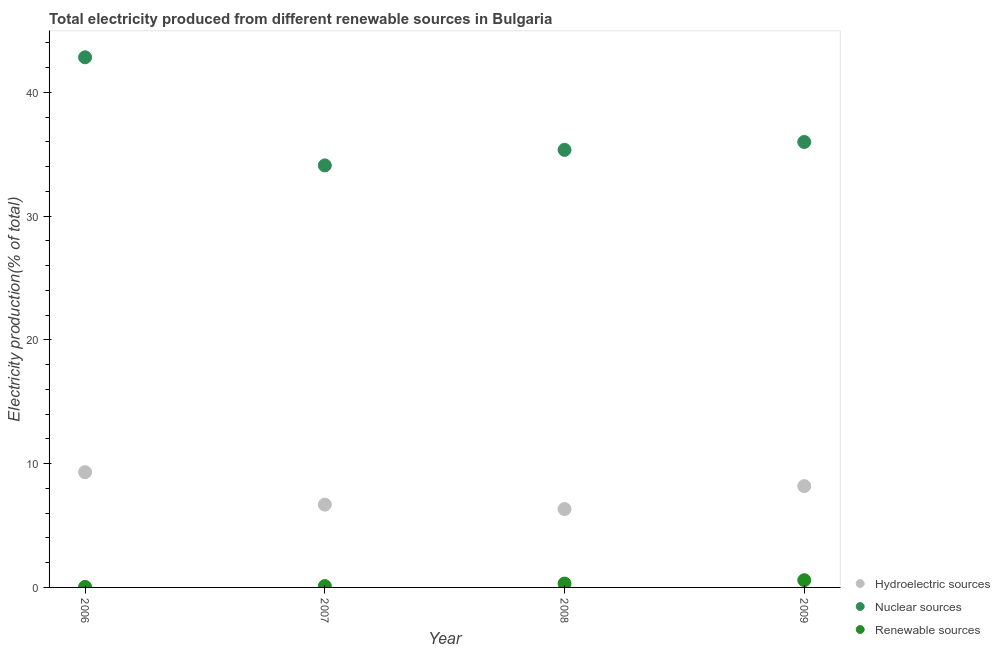How many different coloured dotlines are there?
Give a very brief answer. 3. Is the number of dotlines equal to the number of legend labels?
Keep it short and to the point. Yes. What is the percentage of electricity produced by renewable sources in 2008?
Your response must be concise. 0.31. Across all years, what is the maximum percentage of electricity produced by nuclear sources?
Give a very brief answer. 42.84. Across all years, what is the minimum percentage of electricity produced by renewable sources?
Your answer should be very brief. 0.04. What is the total percentage of electricity produced by renewable sources in the graph?
Provide a succinct answer. 1.05. What is the difference between the percentage of electricity produced by hydroelectric sources in 2008 and that in 2009?
Offer a very short reply. -1.85. What is the difference between the percentage of electricity produced by renewable sources in 2007 and the percentage of electricity produced by nuclear sources in 2006?
Offer a terse response. -42.73. What is the average percentage of electricity produced by nuclear sources per year?
Ensure brevity in your answer.  37.08. In the year 2007, what is the difference between the percentage of electricity produced by nuclear sources and percentage of electricity produced by renewable sources?
Keep it short and to the point. 33.99. What is the ratio of the percentage of electricity produced by nuclear sources in 2007 to that in 2008?
Offer a very short reply. 0.96. What is the difference between the highest and the second highest percentage of electricity produced by renewable sources?
Your answer should be very brief. 0.28. What is the difference between the highest and the lowest percentage of electricity produced by hydroelectric sources?
Provide a short and direct response. 2.98. Is the sum of the percentage of electricity produced by renewable sources in 2006 and 2008 greater than the maximum percentage of electricity produced by nuclear sources across all years?
Offer a very short reply. No. Does the percentage of electricity produced by hydroelectric sources monotonically increase over the years?
Ensure brevity in your answer.  No. How many dotlines are there?
Your response must be concise. 3. How many years are there in the graph?
Offer a terse response. 4. Does the graph contain any zero values?
Give a very brief answer. No. Where does the legend appear in the graph?
Offer a very short reply. Bottom right. How many legend labels are there?
Make the answer very short. 3. What is the title of the graph?
Offer a terse response. Total electricity produced from different renewable sources in Bulgaria. What is the label or title of the Y-axis?
Offer a terse response. Electricity production(% of total). What is the Electricity production(% of total) of Hydroelectric sources in 2006?
Offer a very short reply. 9.31. What is the Electricity production(% of total) in Nuclear sources in 2006?
Make the answer very short. 42.84. What is the Electricity production(% of total) in Renewable sources in 2006?
Offer a terse response. 0.04. What is the Electricity production(% of total) of Hydroelectric sources in 2007?
Offer a terse response. 6.69. What is the Electricity production(% of total) in Nuclear sources in 2007?
Provide a succinct answer. 34.1. What is the Electricity production(% of total) in Renewable sources in 2007?
Offer a terse response. 0.11. What is the Electricity production(% of total) in Hydroelectric sources in 2008?
Keep it short and to the point. 6.33. What is the Electricity production(% of total) in Nuclear sources in 2008?
Provide a short and direct response. 35.36. What is the Electricity production(% of total) in Renewable sources in 2008?
Offer a very short reply. 0.31. What is the Electricity production(% of total) of Hydroelectric sources in 2009?
Your answer should be compact. 8.19. What is the Electricity production(% of total) of Nuclear sources in 2009?
Make the answer very short. 36. What is the Electricity production(% of total) of Renewable sources in 2009?
Your response must be concise. 0.59. Across all years, what is the maximum Electricity production(% of total) in Hydroelectric sources?
Offer a very short reply. 9.31. Across all years, what is the maximum Electricity production(% of total) in Nuclear sources?
Make the answer very short. 42.84. Across all years, what is the maximum Electricity production(% of total) of Renewable sources?
Keep it short and to the point. 0.59. Across all years, what is the minimum Electricity production(% of total) of Hydroelectric sources?
Your response must be concise. 6.33. Across all years, what is the minimum Electricity production(% of total) in Nuclear sources?
Provide a succinct answer. 34.1. Across all years, what is the minimum Electricity production(% of total) in Renewable sources?
Keep it short and to the point. 0.04. What is the total Electricity production(% of total) of Hydroelectric sources in the graph?
Give a very brief answer. 30.53. What is the total Electricity production(% of total) in Nuclear sources in the graph?
Offer a terse response. 148.3. What is the total Electricity production(% of total) of Renewable sources in the graph?
Provide a short and direct response. 1.05. What is the difference between the Electricity production(% of total) in Hydroelectric sources in 2006 and that in 2007?
Keep it short and to the point. 2.62. What is the difference between the Electricity production(% of total) in Nuclear sources in 2006 and that in 2007?
Provide a short and direct response. 8.74. What is the difference between the Electricity production(% of total) of Renewable sources in 2006 and that in 2007?
Give a very brief answer. -0.07. What is the difference between the Electricity production(% of total) of Hydroelectric sources in 2006 and that in 2008?
Offer a terse response. 2.98. What is the difference between the Electricity production(% of total) in Nuclear sources in 2006 and that in 2008?
Provide a short and direct response. 7.48. What is the difference between the Electricity production(% of total) of Renewable sources in 2006 and that in 2008?
Give a very brief answer. -0.27. What is the difference between the Electricity production(% of total) of Hydroelectric sources in 2006 and that in 2009?
Make the answer very short. 1.13. What is the difference between the Electricity production(% of total) in Nuclear sources in 2006 and that in 2009?
Offer a terse response. 6.84. What is the difference between the Electricity production(% of total) in Renewable sources in 2006 and that in 2009?
Offer a terse response. -0.54. What is the difference between the Electricity production(% of total) of Hydroelectric sources in 2007 and that in 2008?
Give a very brief answer. 0.36. What is the difference between the Electricity production(% of total) of Nuclear sources in 2007 and that in 2008?
Ensure brevity in your answer.  -1.26. What is the difference between the Electricity production(% of total) in Renewable sources in 2007 and that in 2008?
Give a very brief answer. -0.2. What is the difference between the Electricity production(% of total) of Hydroelectric sources in 2007 and that in 2009?
Keep it short and to the point. -1.49. What is the difference between the Electricity production(% of total) in Nuclear sources in 2007 and that in 2009?
Offer a very short reply. -1.89. What is the difference between the Electricity production(% of total) of Renewable sources in 2007 and that in 2009?
Offer a very short reply. -0.48. What is the difference between the Electricity production(% of total) in Hydroelectric sources in 2008 and that in 2009?
Give a very brief answer. -1.85. What is the difference between the Electricity production(% of total) of Nuclear sources in 2008 and that in 2009?
Your response must be concise. -0.64. What is the difference between the Electricity production(% of total) in Renewable sources in 2008 and that in 2009?
Offer a terse response. -0.28. What is the difference between the Electricity production(% of total) of Hydroelectric sources in 2006 and the Electricity production(% of total) of Nuclear sources in 2007?
Give a very brief answer. -24.79. What is the difference between the Electricity production(% of total) in Hydroelectric sources in 2006 and the Electricity production(% of total) in Renewable sources in 2007?
Offer a terse response. 9.2. What is the difference between the Electricity production(% of total) in Nuclear sources in 2006 and the Electricity production(% of total) in Renewable sources in 2007?
Provide a succinct answer. 42.73. What is the difference between the Electricity production(% of total) of Hydroelectric sources in 2006 and the Electricity production(% of total) of Nuclear sources in 2008?
Give a very brief answer. -26.05. What is the difference between the Electricity production(% of total) of Hydroelectric sources in 2006 and the Electricity production(% of total) of Renewable sources in 2008?
Ensure brevity in your answer.  9. What is the difference between the Electricity production(% of total) of Nuclear sources in 2006 and the Electricity production(% of total) of Renewable sources in 2008?
Your response must be concise. 42.53. What is the difference between the Electricity production(% of total) in Hydroelectric sources in 2006 and the Electricity production(% of total) in Nuclear sources in 2009?
Provide a succinct answer. -26.68. What is the difference between the Electricity production(% of total) of Hydroelectric sources in 2006 and the Electricity production(% of total) of Renewable sources in 2009?
Keep it short and to the point. 8.73. What is the difference between the Electricity production(% of total) in Nuclear sources in 2006 and the Electricity production(% of total) in Renewable sources in 2009?
Make the answer very short. 42.25. What is the difference between the Electricity production(% of total) of Hydroelectric sources in 2007 and the Electricity production(% of total) of Nuclear sources in 2008?
Provide a short and direct response. -28.67. What is the difference between the Electricity production(% of total) in Hydroelectric sources in 2007 and the Electricity production(% of total) in Renewable sources in 2008?
Make the answer very short. 6.38. What is the difference between the Electricity production(% of total) of Nuclear sources in 2007 and the Electricity production(% of total) of Renewable sources in 2008?
Provide a succinct answer. 33.79. What is the difference between the Electricity production(% of total) of Hydroelectric sources in 2007 and the Electricity production(% of total) of Nuclear sources in 2009?
Your response must be concise. -29.3. What is the difference between the Electricity production(% of total) in Hydroelectric sources in 2007 and the Electricity production(% of total) in Renewable sources in 2009?
Keep it short and to the point. 6.11. What is the difference between the Electricity production(% of total) in Nuclear sources in 2007 and the Electricity production(% of total) in Renewable sources in 2009?
Ensure brevity in your answer.  33.52. What is the difference between the Electricity production(% of total) in Hydroelectric sources in 2008 and the Electricity production(% of total) in Nuclear sources in 2009?
Your answer should be very brief. -29.66. What is the difference between the Electricity production(% of total) in Hydroelectric sources in 2008 and the Electricity production(% of total) in Renewable sources in 2009?
Give a very brief answer. 5.75. What is the difference between the Electricity production(% of total) in Nuclear sources in 2008 and the Electricity production(% of total) in Renewable sources in 2009?
Provide a short and direct response. 34.78. What is the average Electricity production(% of total) in Hydroelectric sources per year?
Provide a succinct answer. 7.63. What is the average Electricity production(% of total) of Nuclear sources per year?
Give a very brief answer. 37.08. What is the average Electricity production(% of total) in Renewable sources per year?
Your answer should be very brief. 0.26. In the year 2006, what is the difference between the Electricity production(% of total) of Hydroelectric sources and Electricity production(% of total) of Nuclear sources?
Your answer should be very brief. -33.53. In the year 2006, what is the difference between the Electricity production(% of total) of Hydroelectric sources and Electricity production(% of total) of Renewable sources?
Your response must be concise. 9.27. In the year 2006, what is the difference between the Electricity production(% of total) in Nuclear sources and Electricity production(% of total) in Renewable sources?
Provide a succinct answer. 42.8. In the year 2007, what is the difference between the Electricity production(% of total) in Hydroelectric sources and Electricity production(% of total) in Nuclear sources?
Offer a terse response. -27.41. In the year 2007, what is the difference between the Electricity production(% of total) in Hydroelectric sources and Electricity production(% of total) in Renewable sources?
Offer a terse response. 6.58. In the year 2007, what is the difference between the Electricity production(% of total) of Nuclear sources and Electricity production(% of total) of Renewable sources?
Offer a terse response. 33.99. In the year 2008, what is the difference between the Electricity production(% of total) in Hydroelectric sources and Electricity production(% of total) in Nuclear sources?
Provide a short and direct response. -29.03. In the year 2008, what is the difference between the Electricity production(% of total) of Hydroelectric sources and Electricity production(% of total) of Renewable sources?
Provide a short and direct response. 6.02. In the year 2008, what is the difference between the Electricity production(% of total) of Nuclear sources and Electricity production(% of total) of Renewable sources?
Your answer should be very brief. 35.05. In the year 2009, what is the difference between the Electricity production(% of total) of Hydroelectric sources and Electricity production(% of total) of Nuclear sources?
Keep it short and to the point. -27.81. In the year 2009, what is the difference between the Electricity production(% of total) in Hydroelectric sources and Electricity production(% of total) in Renewable sources?
Your answer should be compact. 7.6. In the year 2009, what is the difference between the Electricity production(% of total) of Nuclear sources and Electricity production(% of total) of Renewable sources?
Provide a succinct answer. 35.41. What is the ratio of the Electricity production(% of total) in Hydroelectric sources in 2006 to that in 2007?
Offer a very short reply. 1.39. What is the ratio of the Electricity production(% of total) in Nuclear sources in 2006 to that in 2007?
Keep it short and to the point. 1.26. What is the ratio of the Electricity production(% of total) in Renewable sources in 2006 to that in 2007?
Your response must be concise. 0.4. What is the ratio of the Electricity production(% of total) of Hydroelectric sources in 2006 to that in 2008?
Make the answer very short. 1.47. What is the ratio of the Electricity production(% of total) of Nuclear sources in 2006 to that in 2008?
Provide a short and direct response. 1.21. What is the ratio of the Electricity production(% of total) of Renewable sources in 2006 to that in 2008?
Provide a succinct answer. 0.14. What is the ratio of the Electricity production(% of total) in Hydroelectric sources in 2006 to that in 2009?
Ensure brevity in your answer.  1.14. What is the ratio of the Electricity production(% of total) of Nuclear sources in 2006 to that in 2009?
Offer a very short reply. 1.19. What is the ratio of the Electricity production(% of total) in Renewable sources in 2006 to that in 2009?
Your answer should be very brief. 0.08. What is the ratio of the Electricity production(% of total) of Hydroelectric sources in 2007 to that in 2008?
Your answer should be very brief. 1.06. What is the ratio of the Electricity production(% of total) of Nuclear sources in 2007 to that in 2008?
Give a very brief answer. 0.96. What is the ratio of the Electricity production(% of total) of Renewable sources in 2007 to that in 2008?
Ensure brevity in your answer.  0.35. What is the ratio of the Electricity production(% of total) of Hydroelectric sources in 2007 to that in 2009?
Ensure brevity in your answer.  0.82. What is the ratio of the Electricity production(% of total) in Nuclear sources in 2007 to that in 2009?
Your response must be concise. 0.95. What is the ratio of the Electricity production(% of total) in Renewable sources in 2007 to that in 2009?
Your response must be concise. 0.19. What is the ratio of the Electricity production(% of total) in Hydroelectric sources in 2008 to that in 2009?
Give a very brief answer. 0.77. What is the ratio of the Electricity production(% of total) in Nuclear sources in 2008 to that in 2009?
Provide a short and direct response. 0.98. What is the ratio of the Electricity production(% of total) of Renewable sources in 2008 to that in 2009?
Give a very brief answer. 0.53. What is the difference between the highest and the second highest Electricity production(% of total) in Hydroelectric sources?
Offer a terse response. 1.13. What is the difference between the highest and the second highest Electricity production(% of total) in Nuclear sources?
Provide a short and direct response. 6.84. What is the difference between the highest and the second highest Electricity production(% of total) of Renewable sources?
Offer a very short reply. 0.28. What is the difference between the highest and the lowest Electricity production(% of total) of Hydroelectric sources?
Offer a very short reply. 2.98. What is the difference between the highest and the lowest Electricity production(% of total) in Nuclear sources?
Offer a very short reply. 8.74. What is the difference between the highest and the lowest Electricity production(% of total) in Renewable sources?
Offer a terse response. 0.54. 